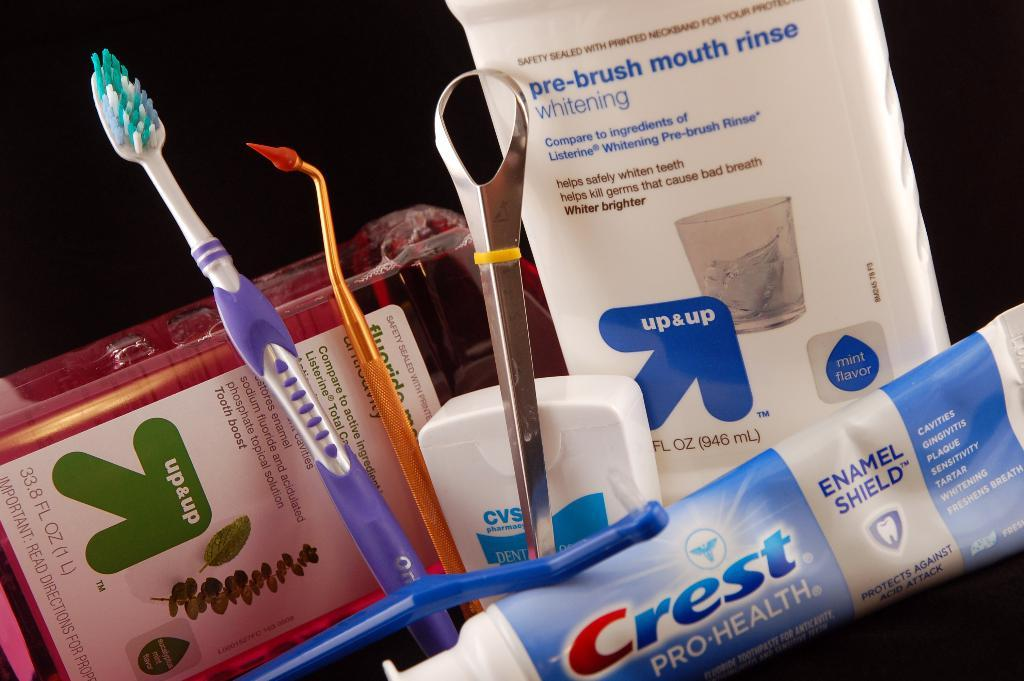<image>
Write a terse but informative summary of the picture. toothpaste products by crest and generic mouth wash rinse 